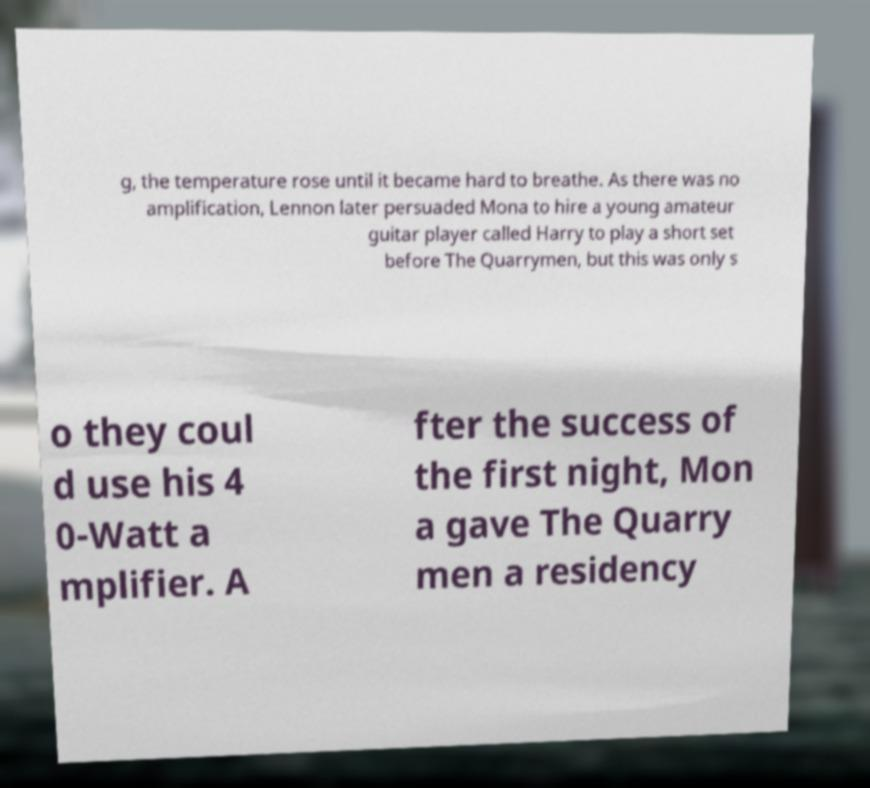For documentation purposes, I need the text within this image transcribed. Could you provide that? g, the temperature rose until it became hard to breathe. As there was no amplification, Lennon later persuaded Mona to hire a young amateur guitar player called Harry to play a short set before The Quarrymen, but this was only s o they coul d use his 4 0-Watt a mplifier. A fter the success of the first night, Mon a gave The Quarry men a residency 